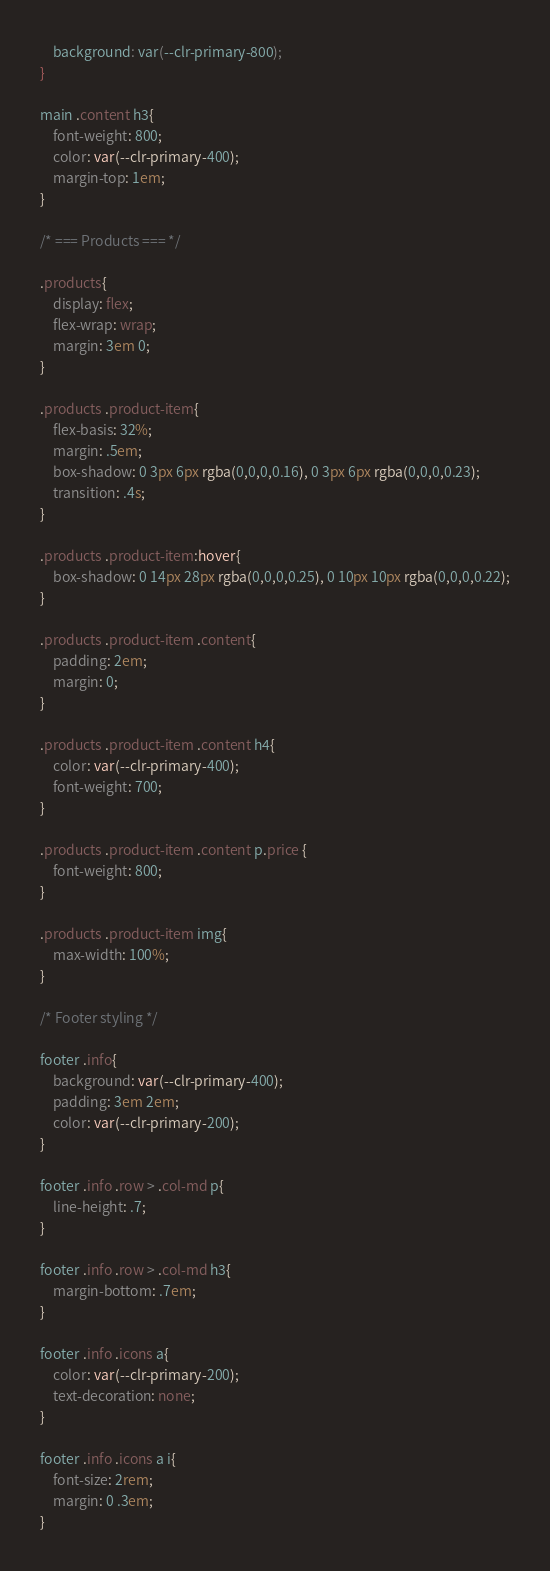<code> <loc_0><loc_0><loc_500><loc_500><_CSS_>	background: var(--clr-primary-800);
}

main .content h3{
	font-weight: 800;
	color: var(--clr-primary-400);
	margin-top: 1em;
}

/* === Products === */

.products{
	display: flex;
	flex-wrap: wrap;
	margin: 3em 0;
}

.products .product-item{
	flex-basis: 32%;
	margin: .5em;
	box-shadow: 0 3px 6px rgba(0,0,0,0.16), 0 3px 6px rgba(0,0,0,0.23);
	transition: .4s;
}

.products .product-item:hover{
	box-shadow: 0 14px 28px rgba(0,0,0,0.25), 0 10px 10px rgba(0,0,0,0.22);
}

.products .product-item .content{
	padding: 2em;
	margin: 0;
}

.products .product-item .content h4{
	color: var(--clr-primary-400);
	font-weight: 700;
}

.products .product-item .content p.price {
	font-weight: 800;
}

.products .product-item img{
	max-width: 100%;
}

/* Footer styling */

footer .info{
	background: var(--clr-primary-400);
	padding: 3em 2em;
	color: var(--clr-primary-200);
}

footer .info .row > .col-md p{
	line-height: .7;
}

footer .info .row > .col-md h3{
	margin-bottom: .7em;
}

footer .info .icons a{
	color: var(--clr-primary-200);
	text-decoration: none;
}

footer .info .icons a i{
	font-size: 2rem;
	margin: 0 .3em;
}</code> 